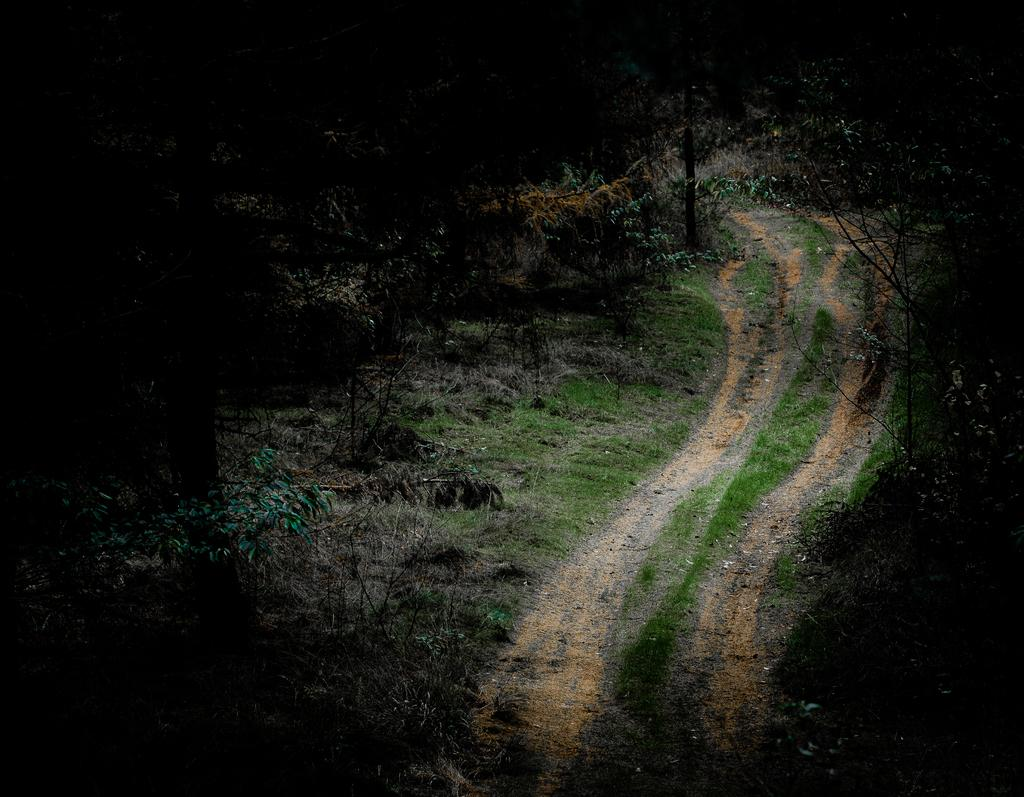What is the main feature in the center of the image? There is a walkway in the center of the image. What type of vegetation can be seen on the right side of the image? There are trees and plants on the right side of the image. What type of vegetation can be seen on the left side of the image? There are trees and plants on the left side of the image. What type of mark can be seen on the trees in the image? There are no marks visible on the trees in the image. What event is taking place in the image? There is no event depicted in the image; it simply shows a walkway with trees and plants on both sides. 